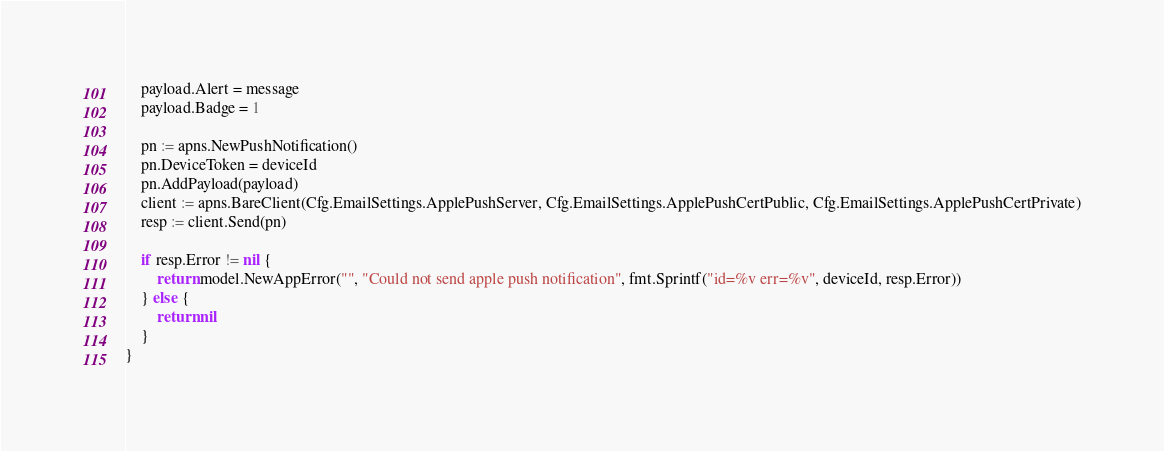Convert code to text. <code><loc_0><loc_0><loc_500><loc_500><_Go_>	payload.Alert = message
	payload.Badge = 1

	pn := apns.NewPushNotification()
	pn.DeviceToken = deviceId
	pn.AddPayload(payload)
	client := apns.BareClient(Cfg.EmailSettings.ApplePushServer, Cfg.EmailSettings.ApplePushCertPublic, Cfg.EmailSettings.ApplePushCertPrivate)
	resp := client.Send(pn)

	if resp.Error != nil {
		return model.NewAppError("", "Could not send apple push notification", fmt.Sprintf("id=%v err=%v", deviceId, resp.Error))
	} else {
		return nil
	}
}
</code> 